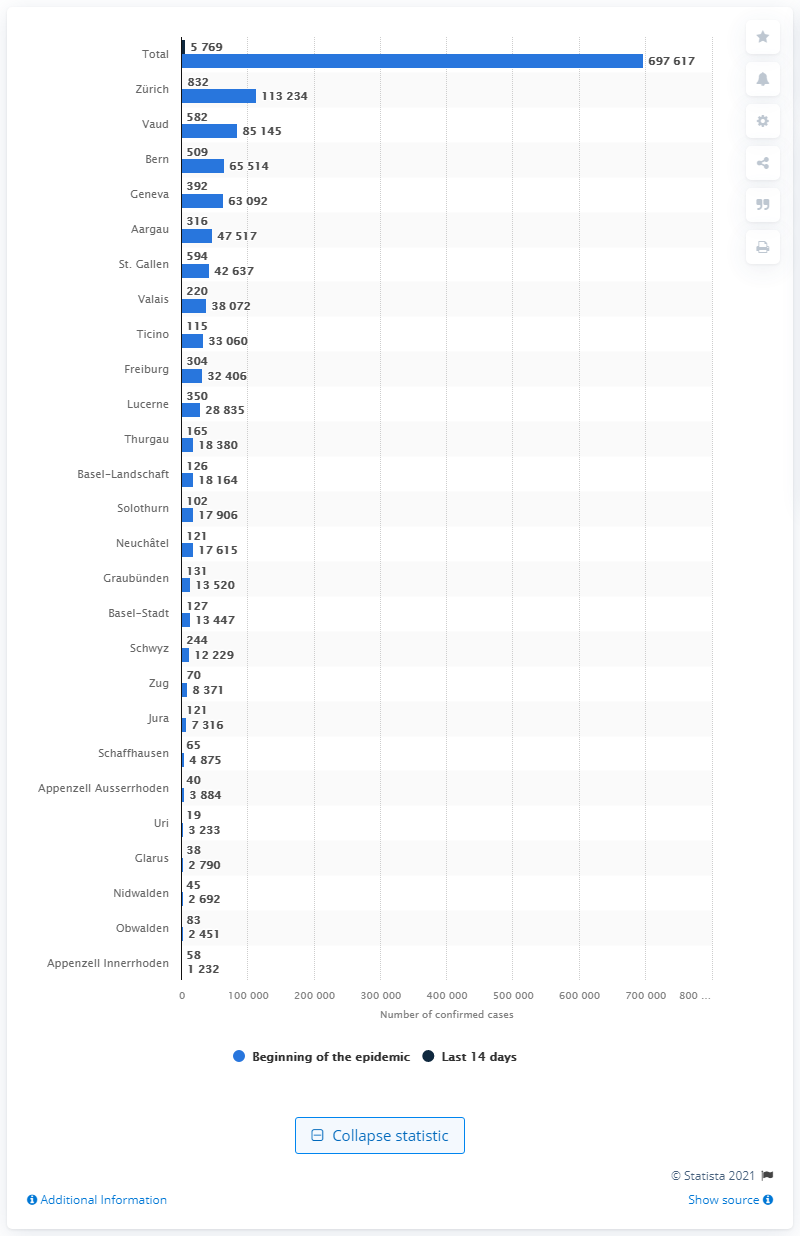Mention a couple of crucial points in this snapshot. Vaud is the canton with the highest number of confirmed cases of COVID-19 in Switzerland. 